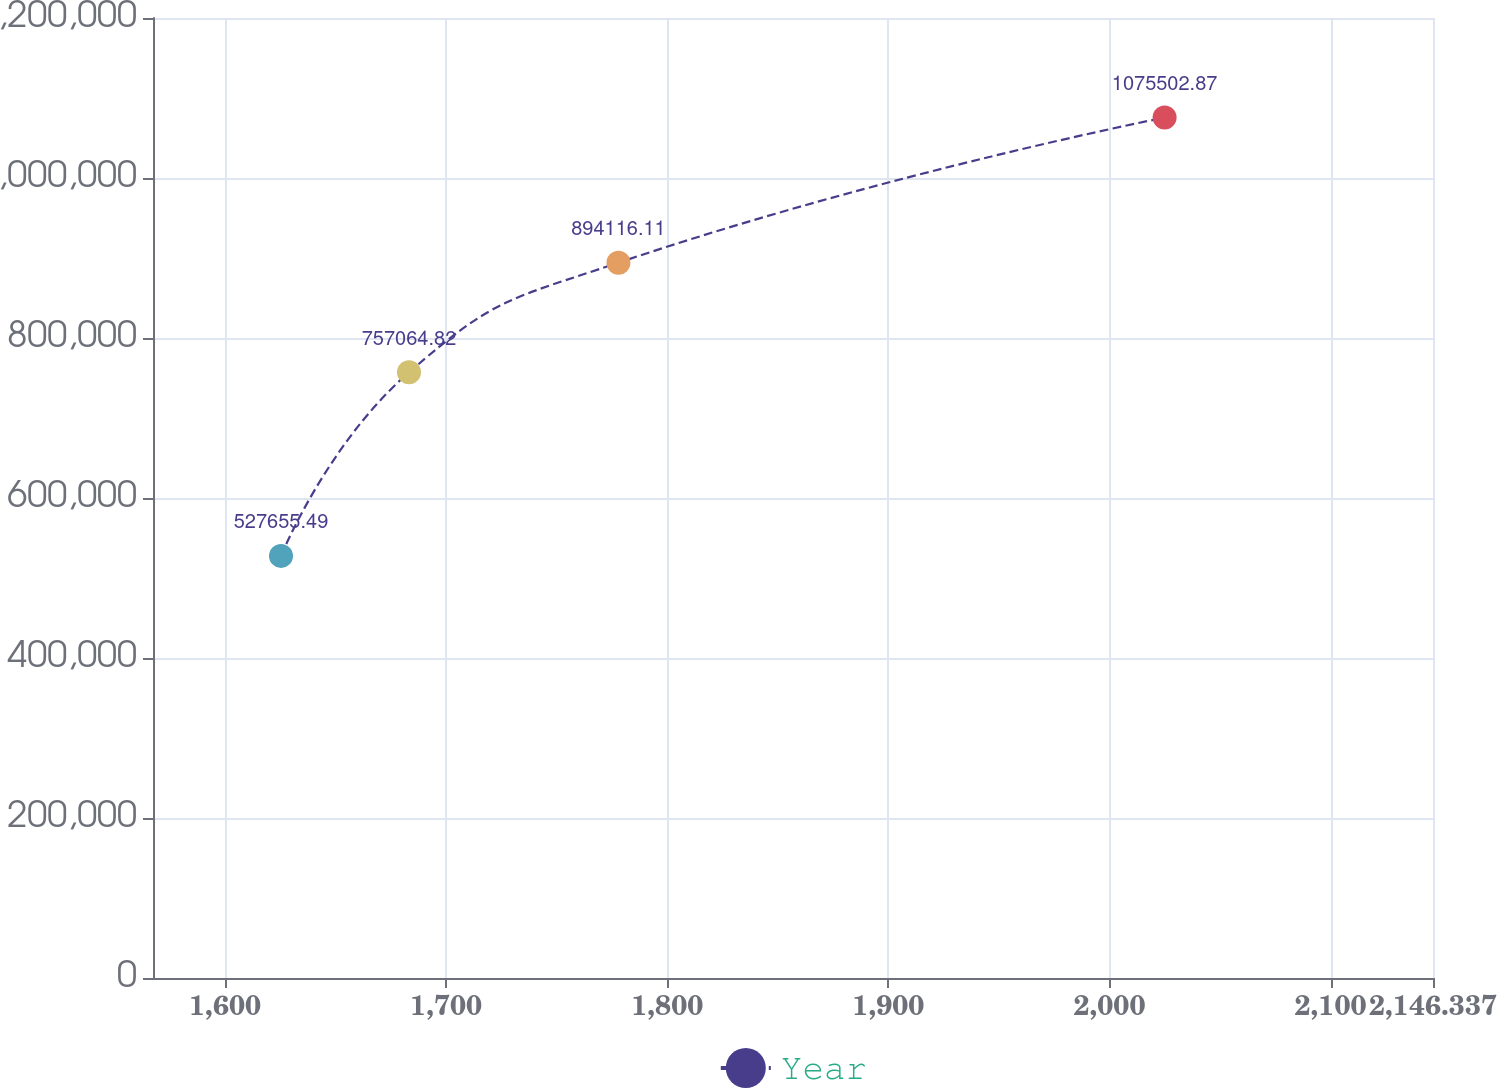<chart> <loc_0><loc_0><loc_500><loc_500><line_chart><ecel><fcel>Year<nl><fcel>1625.3<fcel>527655<nl><fcel>1683.19<fcel>757065<nl><fcel>1777.92<fcel>894116<nl><fcel>2024.94<fcel>1.0755e+06<nl><fcel>2204.23<fcel>948901<nl></chart> 